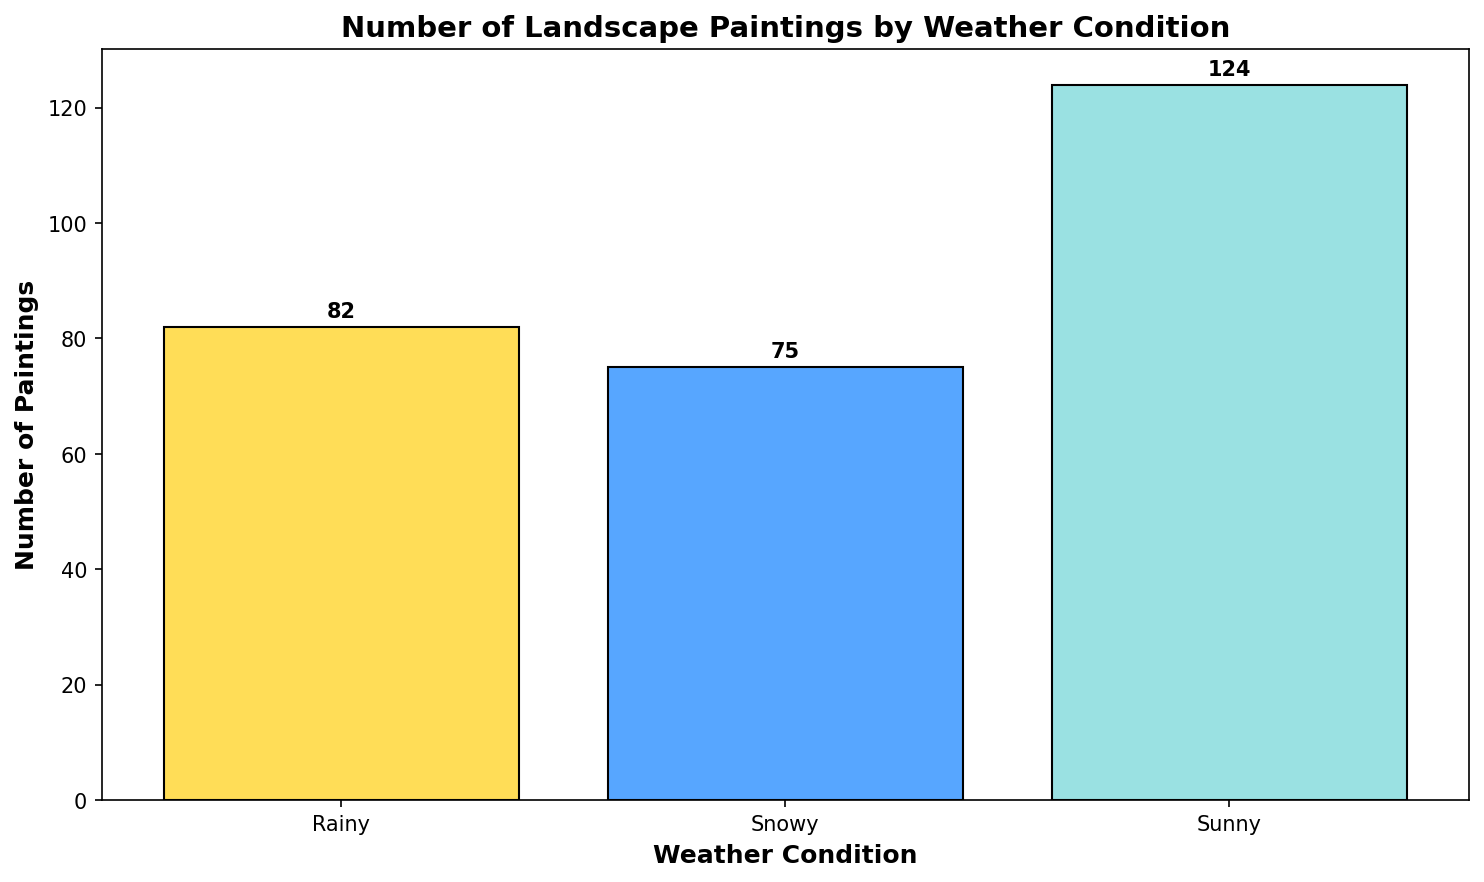What's the total number of paintings featuring rainy weather? To find the total number of paintings with rainy weather, add the numbers from all entries labeled "Rainy": 15 + 20 + 10 + 25 + 12 = 82.
Answer: 82 How many more paintings feature sunny weather compared to snowy weather? First, sum the number of sunny weather paintings: 25 + 18 + 22 + 30 + 29 = 124. Then, sum the number of snowy weather paintings: 12 + 14 + 16 + 18 + 15 = 75. Finally, subtract the total number of snowy paintings from the total number of sunny paintings: 124 - 75 = 49.
Answer: 49 Which weather condition is featured in the most paintings? By observing the heights of the bars, it's clear that the bar representing "Sunny" is the tallest, indicating that sunny weather is featured in the most paintings.
Answer: Sunny What's the average number of paintings for each weather condition? First, find the total number of paintings for each condition: Sunny is 124, Rainy is 82, Snowy is 75. Then, divide each total by the number of entries (which is 5): Sunny: 124/5 = 24.8, Rainy: 82/5 = 16.4, Snowy: 75/5 = 15.
Answer: Sunny: 24.8, Rainy: 16.4, Snowy: 15 What is the difference in the total number of paintings between the most and least featured weather conditions? Calculate the total number of paintings for each condition: Sunny (124), Rainy (82), Snowy (75). The difference between the most featured (Sunny) and the least featured (Snowy) is 124 - 75 = 49.
Answer: 49 What proportion of the paintings feature snowy weather? First, calculate the total number of paintings across all weather conditions: 124 (Sunny) + 82 (Rainy) + 75 (Snowy) = 281. Then, find the proportion of snowy weather paintings: 75 / 281 ≈ 0.267, or approximately 26.7%.
Answer: 26.7% Which weather condition has the median number of paintings? List the total number of paintings for each condition: 124 (Sunny), 82 (Rainy), 75 (Snowy). The median value is the middle number when these are arranged in order: 75, 82, 124. The median is 82, which corresponds to Rainy weather.
Answer: Rainy Which color represents snowy weather in the chart? By observing the colors of the bars, snowy weather is represented by a bar colored in a bluish hue.
Answer: Bluish How many fewer paintings are there featuring rainy weather compared to snowy and sunny weather combined? First, find the total number of rainy weather paintings: 82. Then, sum the total number of snowy and sunny paintings together: 75 (Snowy) + 124 (Sunny) = 199. Subtract the total rainy paintings from this sum: 199 - 82 = 117.
Answer: 117 